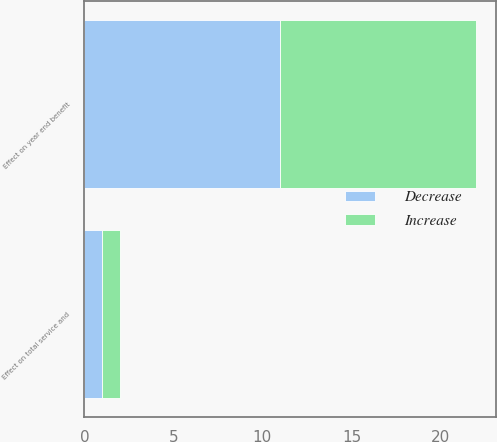<chart> <loc_0><loc_0><loc_500><loc_500><stacked_bar_chart><ecel><fcel>Effect on total service and<fcel>Effect on year end benefit<nl><fcel>Decrease<fcel>1<fcel>11<nl><fcel>Increase<fcel>1<fcel>11<nl></chart> 